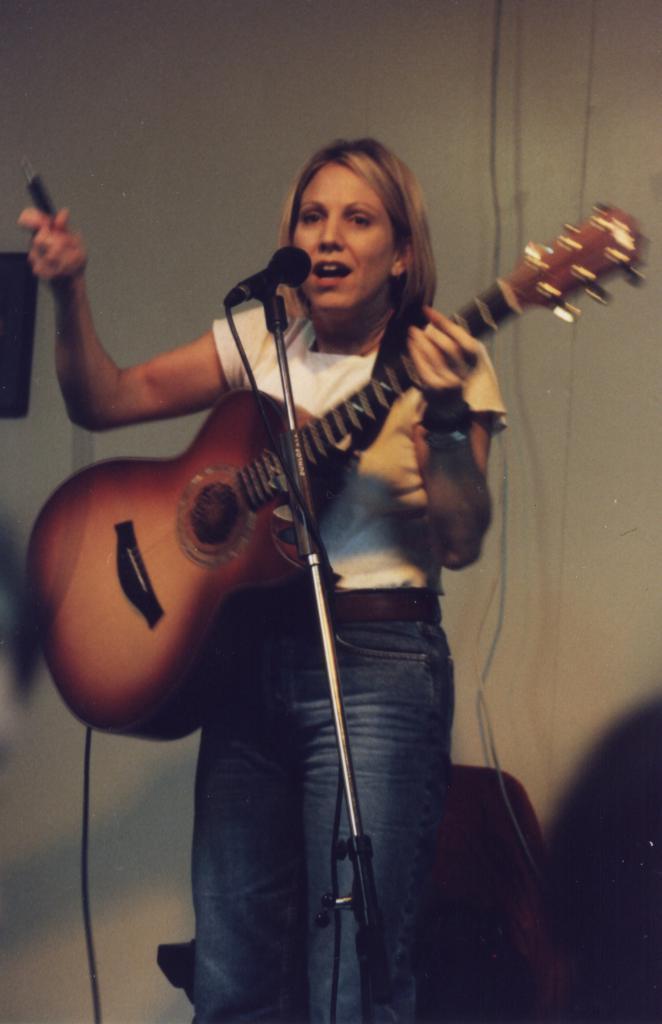Can you describe this image briefly? In the image we can see there is a woman who is standing and holding guitar in her hand. 